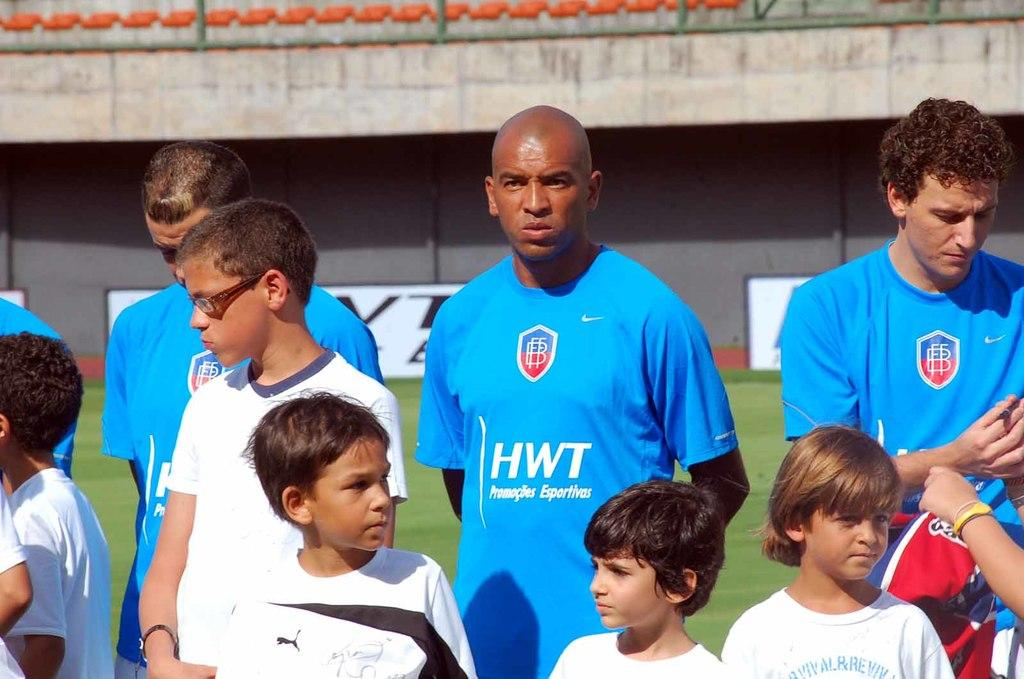Provide a one-sentence caption for the provided image. Men wearing blue HWT shirts stand behind a group of children. 